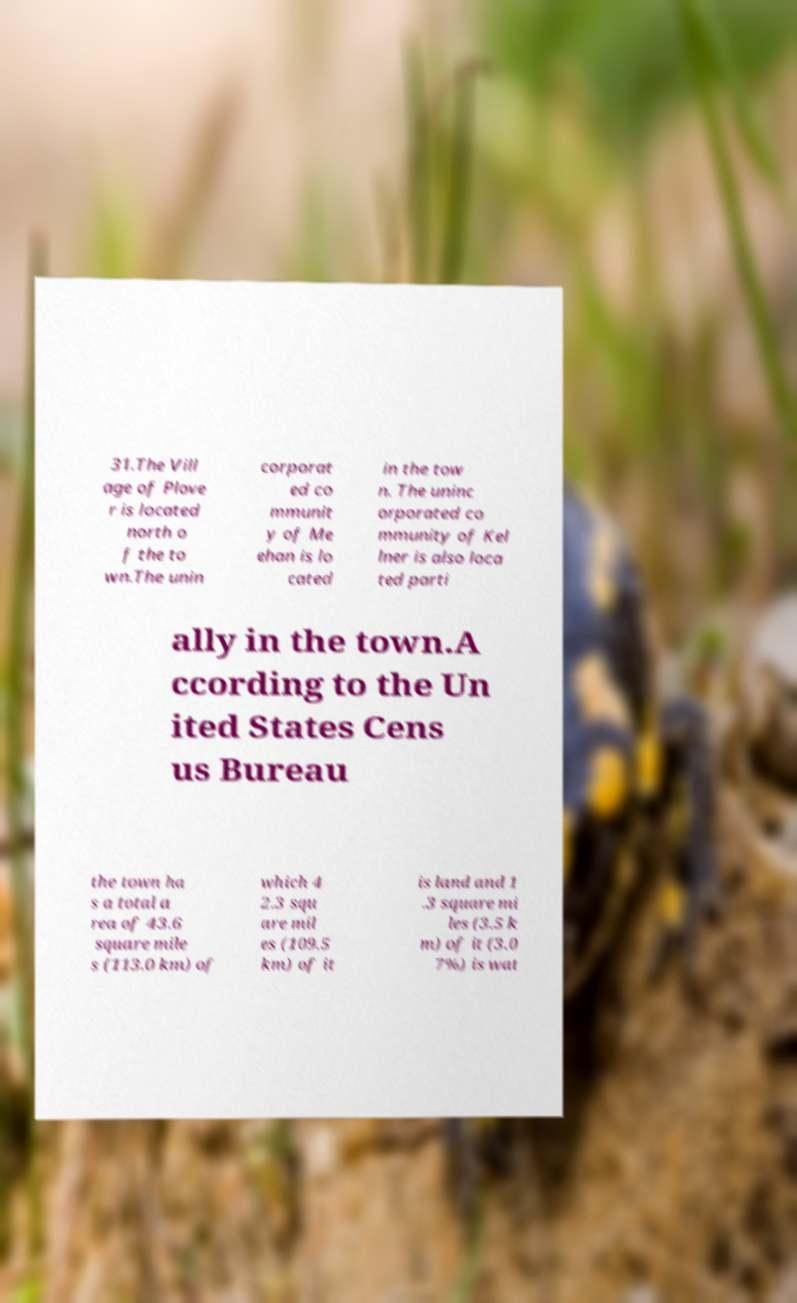Please identify and transcribe the text found in this image. 31.The Vill age of Plove r is located north o f the to wn.The unin corporat ed co mmunit y of Me ehan is lo cated in the tow n. The uninc orporated co mmunity of Kel lner is also loca ted parti ally in the town.A ccording to the Un ited States Cens us Bureau the town ha s a total a rea of 43.6 square mile s (113.0 km) of which 4 2.3 squ are mil es (109.5 km) of it is land and 1 .3 square mi les (3.5 k m) of it (3.0 7%) is wat 